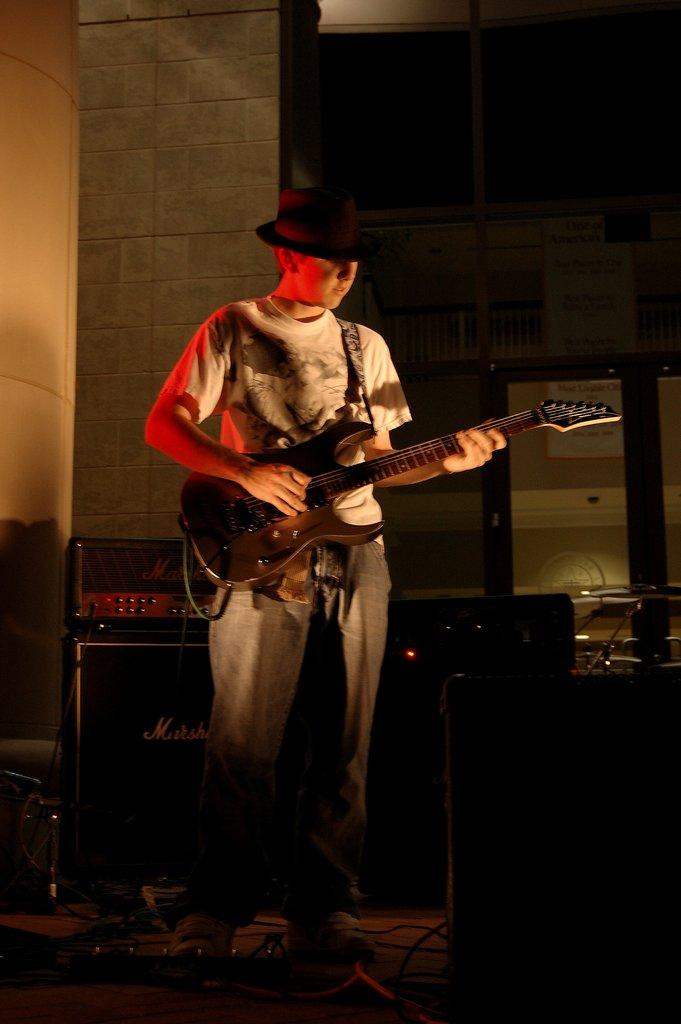What is the man in the image doing? The man is playing the guitar. What is the man wearing on his head? The man is wearing a cap. What instrument is the man holding? The man is holding a guitar. What can be seen in the background of the image? There is a table, speakers, and a wall in the background of the image. What type of friction is the man experiencing while playing the guitar in the image? There is no information about the type of friction the man is experiencing while playing the guitar in the image. What kind of rock is visible on the wall in the background of the image? There is no rock visible on the wall in the background of the image. 